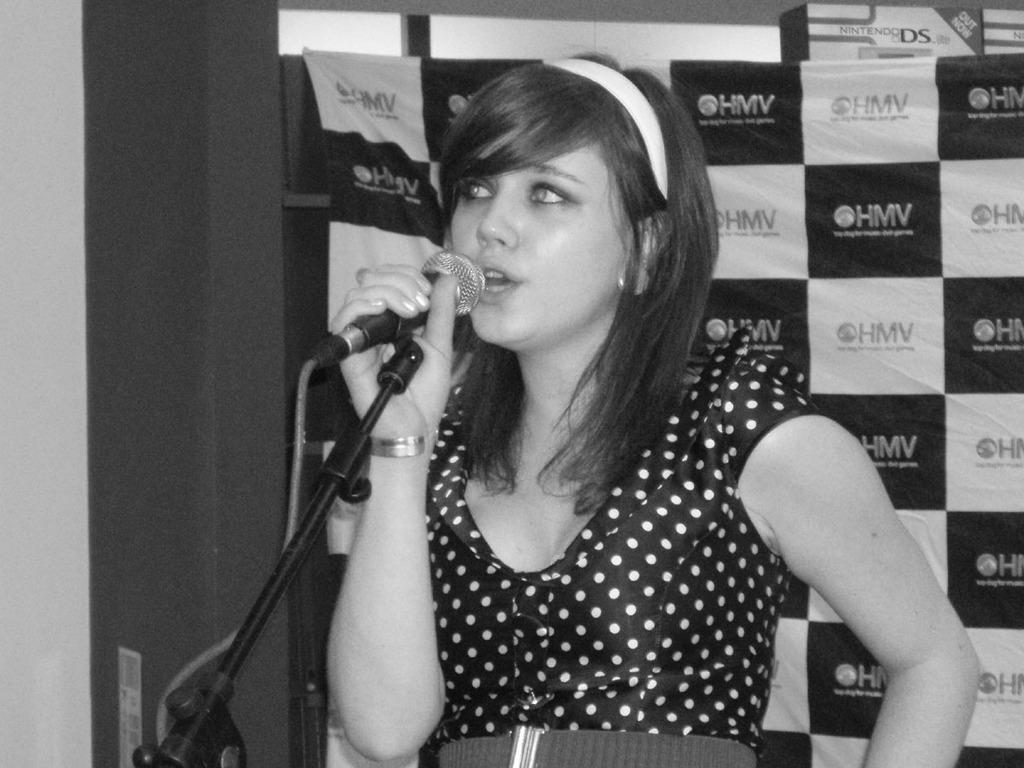Who is the main subject in the image? There is a woman in the image. What is the woman holding in the image? The woman is holding a microphone. What is the woman doing in the image? The woman is singing. What else can be seen in the image? There is a banner visible in the image. What type of tomatoes are being used to support the beam in the image? There are no tomatoes or beams present in the image. What advice is the woman giving to the audience in the image? The woman is singing, not giving advice, in the image. 